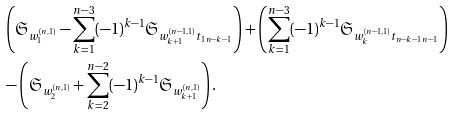<formula> <loc_0><loc_0><loc_500><loc_500>& \left ( \mathfrak { S } _ { w _ { 1 } ^ { ( n , 1 ) } } - \sum _ { k = 1 } ^ { n - 3 } ( - 1 ) ^ { k - 1 } \mathfrak { S } _ { w _ { k + 1 } ^ { ( n - 1 , 1 ) } t _ { 1 \, n - k - 1 } } \right ) + \left ( \sum _ { k = 1 } ^ { n - 3 } ( - 1 ) ^ { k - 1 } \mathfrak { S } _ { w _ { k } ^ { ( n - 1 , 1 ) } t _ { n - k - 1 \, n - 1 } } \right ) \\ & - \left ( \mathfrak { S } _ { w _ { 2 } ^ { ( n , 1 ) } } + \sum _ { k = 2 } ^ { n - 2 } ( - 1 ) ^ { k - 1 } \mathfrak { S } _ { w _ { k + 1 } ^ { ( n , 1 ) } } \right ) .</formula> 